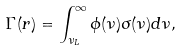<formula> <loc_0><loc_0><loc_500><loc_500>\Gamma ( r ) = \int _ { \nu _ { L } } ^ { \infty } \phi ( \nu ) \sigma ( \nu ) d \nu ,</formula> 